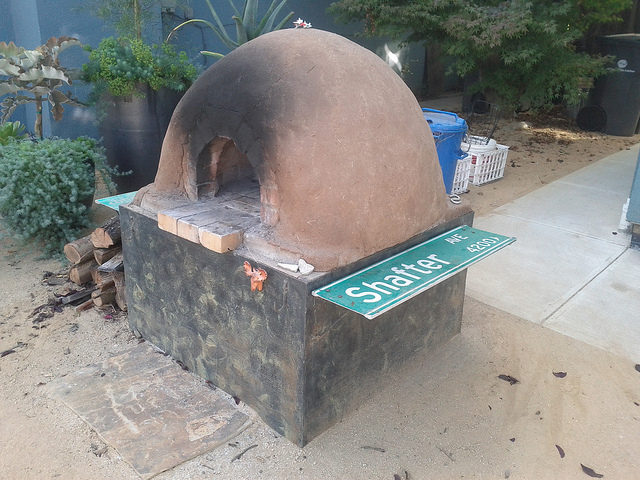Extract all visible text content from this image. Shafter 42001 